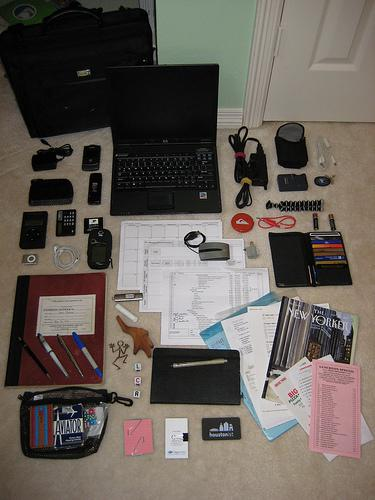Question: how many batteries are there?
Choices:
A. 2.
B. 4.
C. 5.
D. 3.
Answer with the letter. Answer: A Question: what is written on the dice?
Choices:
A. 1, 2, 3.
B. L, C, R.
C. A, b, c.
D. Just dots.
Answer with the letter. Answer: B Question: what is the name of the magazine?
Choices:
A. Time.
B. The New Yorker.
C. People.
D. Playboy.
Answer with the letter. Answer: B Question: how many pens are on the notebook?
Choices:
A. 3.
B. 1.
C. 2.
D. 4.
Answer with the letter. Answer: D 